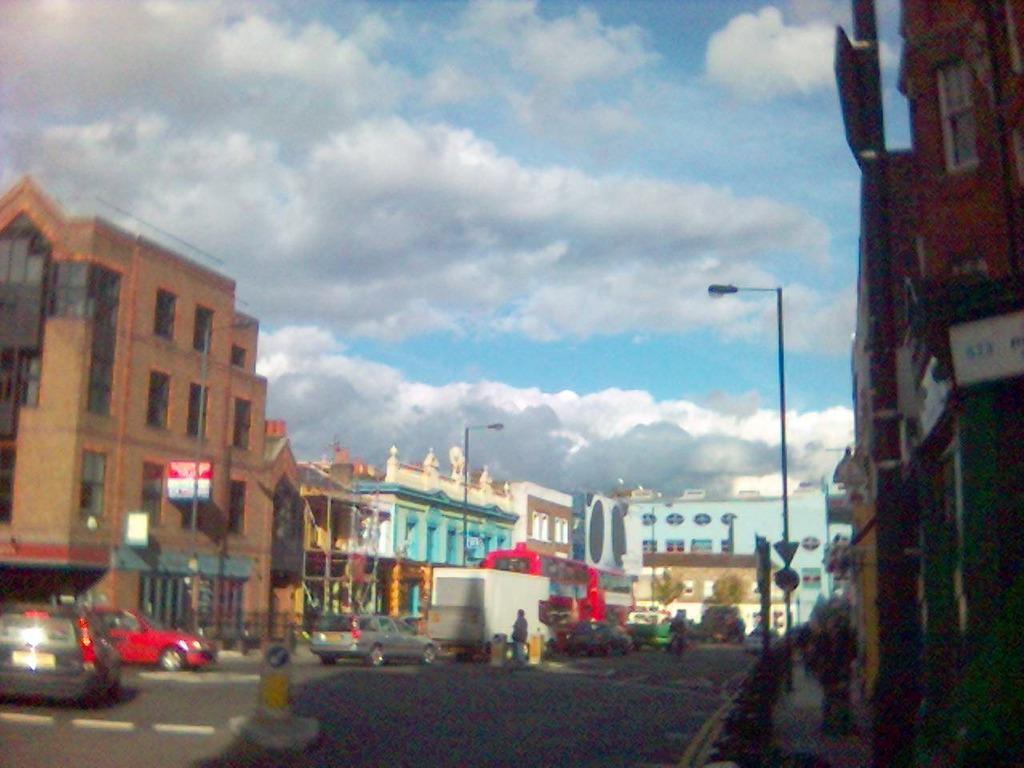Could you give a brief overview of what you see in this image? In this image I can see vehicles on the road. In the background I can see buildings, poles and other objects. I can also see the sky. 